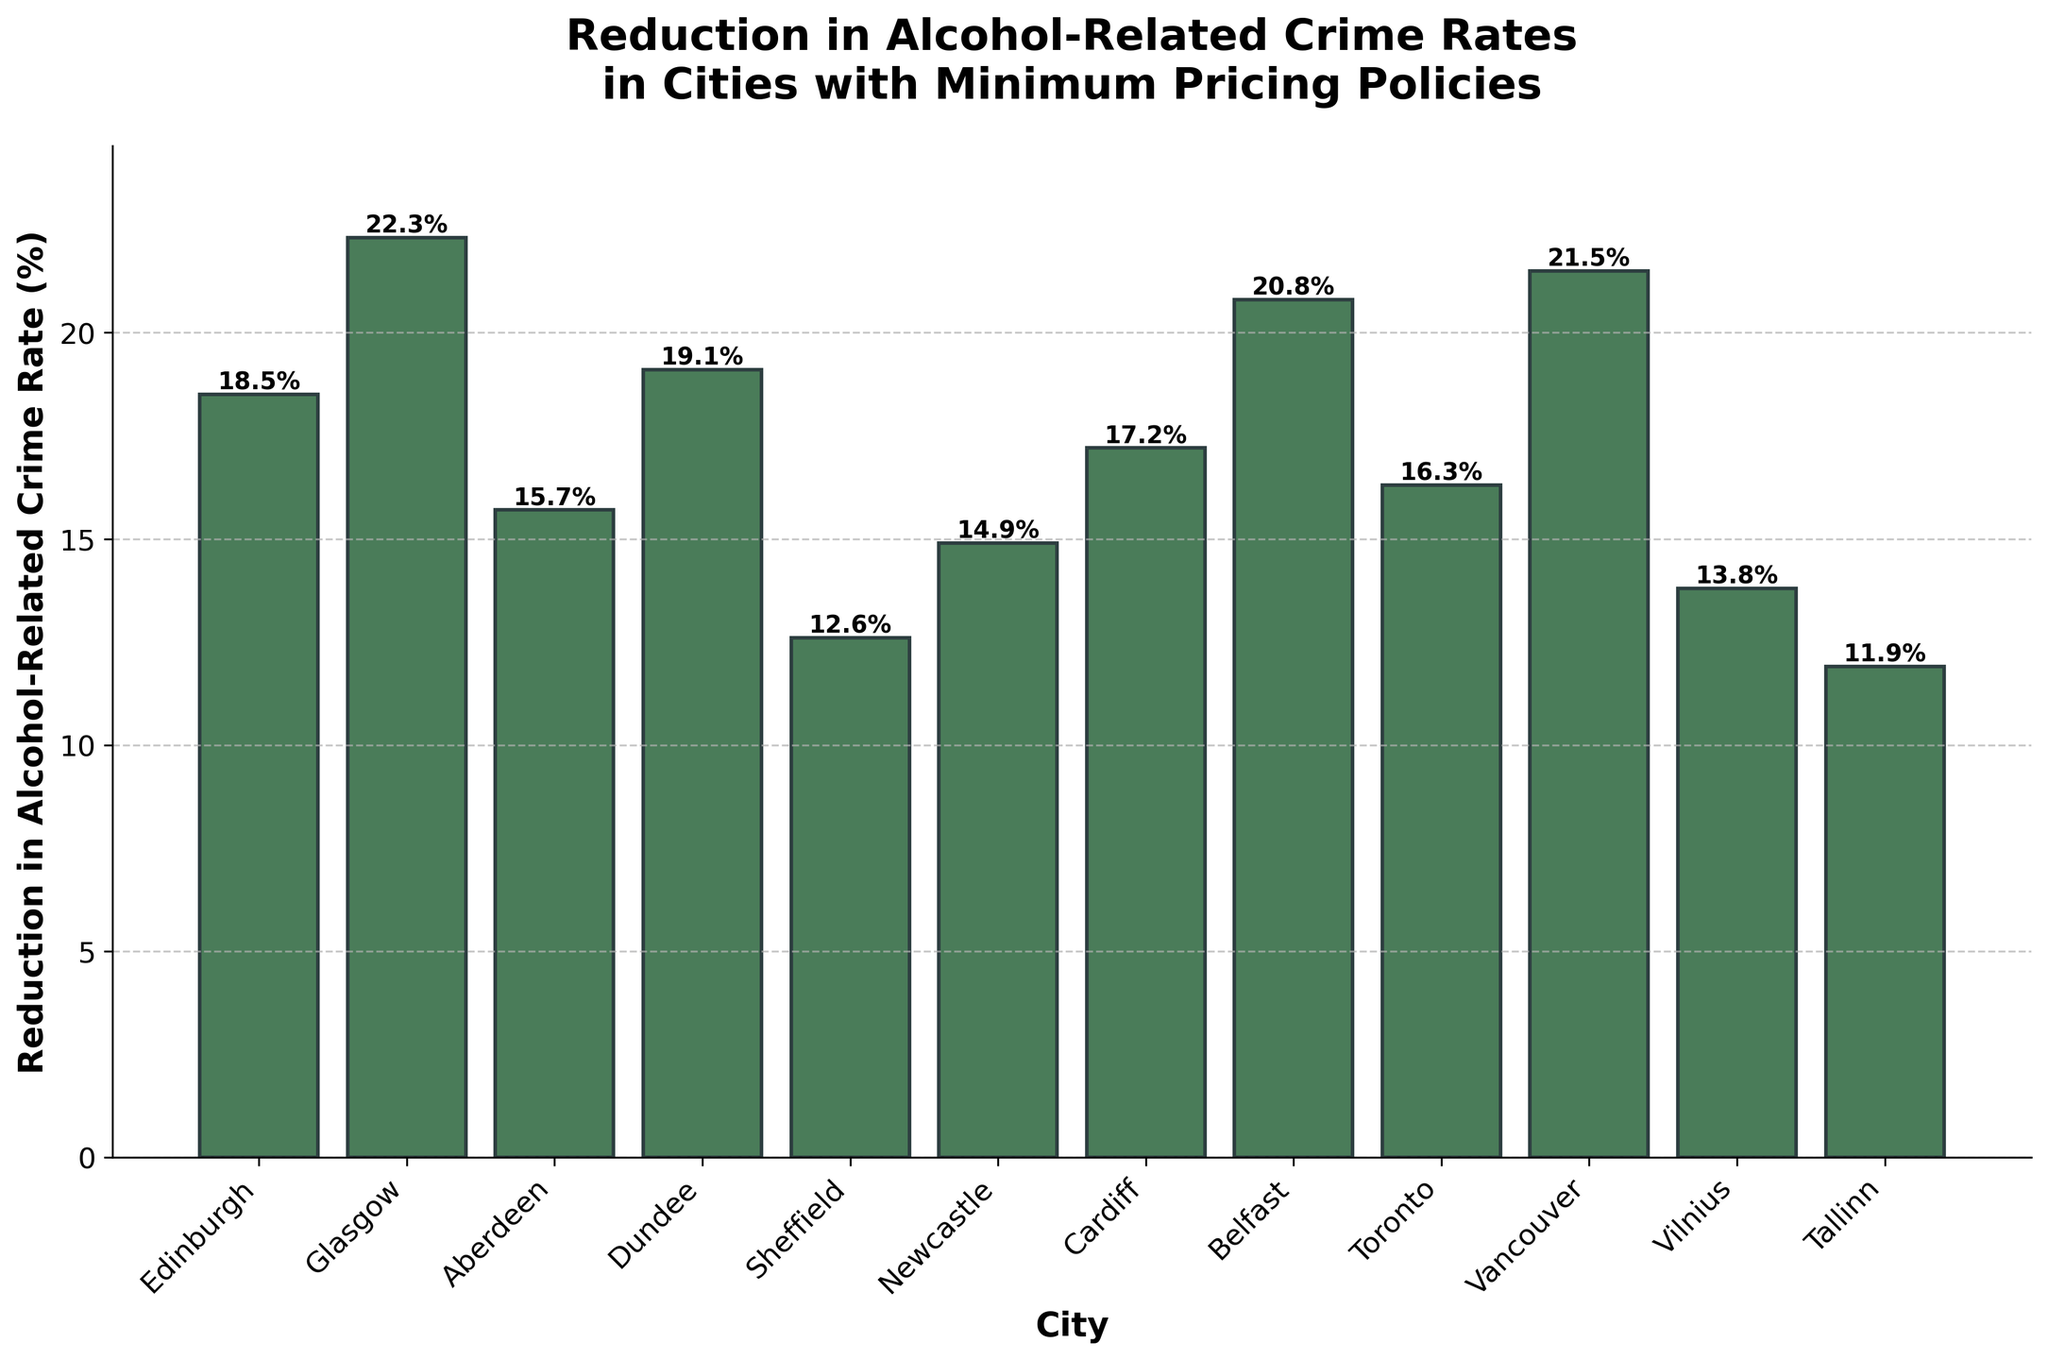What is the highest reduction in alcohol-related crime rates among the cities? To find the highest reduction, observe the bar that extends the furthest upward. Glasgow's bar is the highest, indicating the largest reduction rate.
Answer: 22.3% Which city has the lowest reduction in alcohol-related crime rates? To identify the city with the lowest reduction, find the shortest bar. Tallinn has the shortest bar.
Answer: 11.9% How much greater is the reduction in alcohol-related crime rates in Glasgow compared to Sheffield? Find the values for Glasgow and Sheffield, which are 22.3% and 12.6%, respectively. Calculate the difference: 22.3% - 12.6% = 9.7%.
Answer: 9.7% What is the average reduction in alcohol-related crime rates for Edinburgh, Aberdeen, and Dundee? Find the values for Edinburgh (18.5%), Aberdeen (15.7%), and Dundee (19.1%), then calculate the average: (18.5% + 15.7% + 19.1%) / 3 = 17.77%.
Answer: 17.77% Which cities have a reduction rate greater than 20%? Identify the bars with heights above the 20% mark. Glasgow, Belfast, and Vancouver meet this criterion.
Answer: Glasgow, Belfast, Vancouver Is the reduction rate in Vancouver greater than that in Cardiff? Compare the bars for Vancouver (21.5%) and Cardiff (17.2%). Vancouver's bar is taller.
Answer: Yes What is the total reduction in alcohol-related crime rates when combining Edinburgh and Belfast? Add the values for Edinburgh (18.5%) and Belfast (20.8%): 18.5% + 20.8% = 39.3%.
Answer: 39.3% Which city has a reduction rate closest to 15%? Check the bars around the 15% mark. Aberdeen has a rate of 15.7%, which is closest.
Answer: Aberdeen How does the reduction rate in Newcastle compare to that in Toronto? Compare the bars for Newcastle (14.9%) and Toronto (16.3%). Toronto's reduction rate is higher than Newcastle's.
Answer: Toronto's rate is higher What is the difference in reduction rates between the city with the highest rate and the city with the lowest rate? Identify the highest rate (Glasgow at 22.3%) and the lowest rate (Tallinn at 11.9%), then calculate the difference: 22.3% - 11.9% = 10.4%.
Answer: 10.4% 